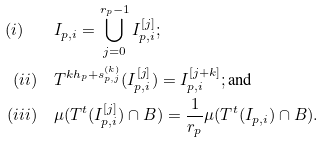<formula> <loc_0><loc_0><loc_500><loc_500>( i ) \quad & I _ { p , i } = \bigcup _ { j = 0 } ^ { r _ { p } - 1 } I _ { p , i } ^ { [ j ] } ; \\ ( i i ) \quad & T ^ { k h _ { p } + s _ { p , j } ^ { ( k ) } } ( I _ { p , i } ^ { [ j ] } ) = I _ { p , i } ^ { [ j + k ] } ; \text {and} \\ ( i i i ) \quad & \mu ( T ^ { t } ( I _ { p , i } ^ { [ j ] } ) \cap B ) = \frac { 1 } { r _ { p } } \mu ( T ^ { t } ( I _ { p , i } ) \cap B ) .</formula> 